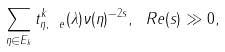Convert formula to latex. <formula><loc_0><loc_0><loc_500><loc_500>\sum _ { \eta \in E _ { k } } t _ { \eta , \ e } ^ { k } ( \lambda ) \nu ( \eta ) ^ { - 2 s } , \ R e ( s ) \gg 0 ,</formula> 